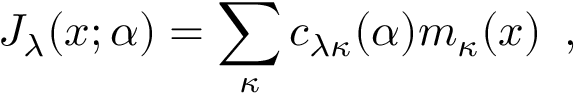Convert formula to latex. <formula><loc_0><loc_0><loc_500><loc_500>J _ { \lambda } ( x ; \alpha ) = \sum _ { \kappa } c _ { \lambda \kappa } ( \alpha ) m _ { \kappa } ( x ) \, ,</formula> 